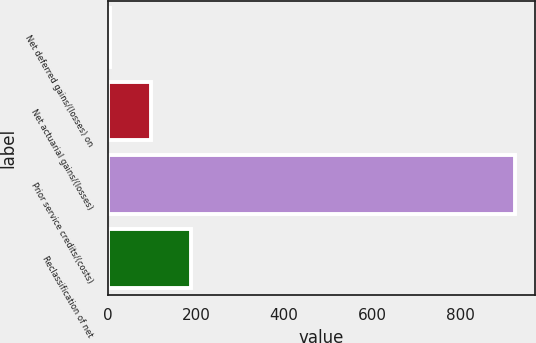Convert chart to OTSL. <chart><loc_0><loc_0><loc_500><loc_500><bar_chart><fcel>Net deferred gains/(losses) on<fcel>Net actuarial gains/(losses)<fcel>Prior service credits/(costs)<fcel>Reclassification of net<nl><fcel>6<fcel>97.7<fcel>923<fcel>189.4<nl></chart> 